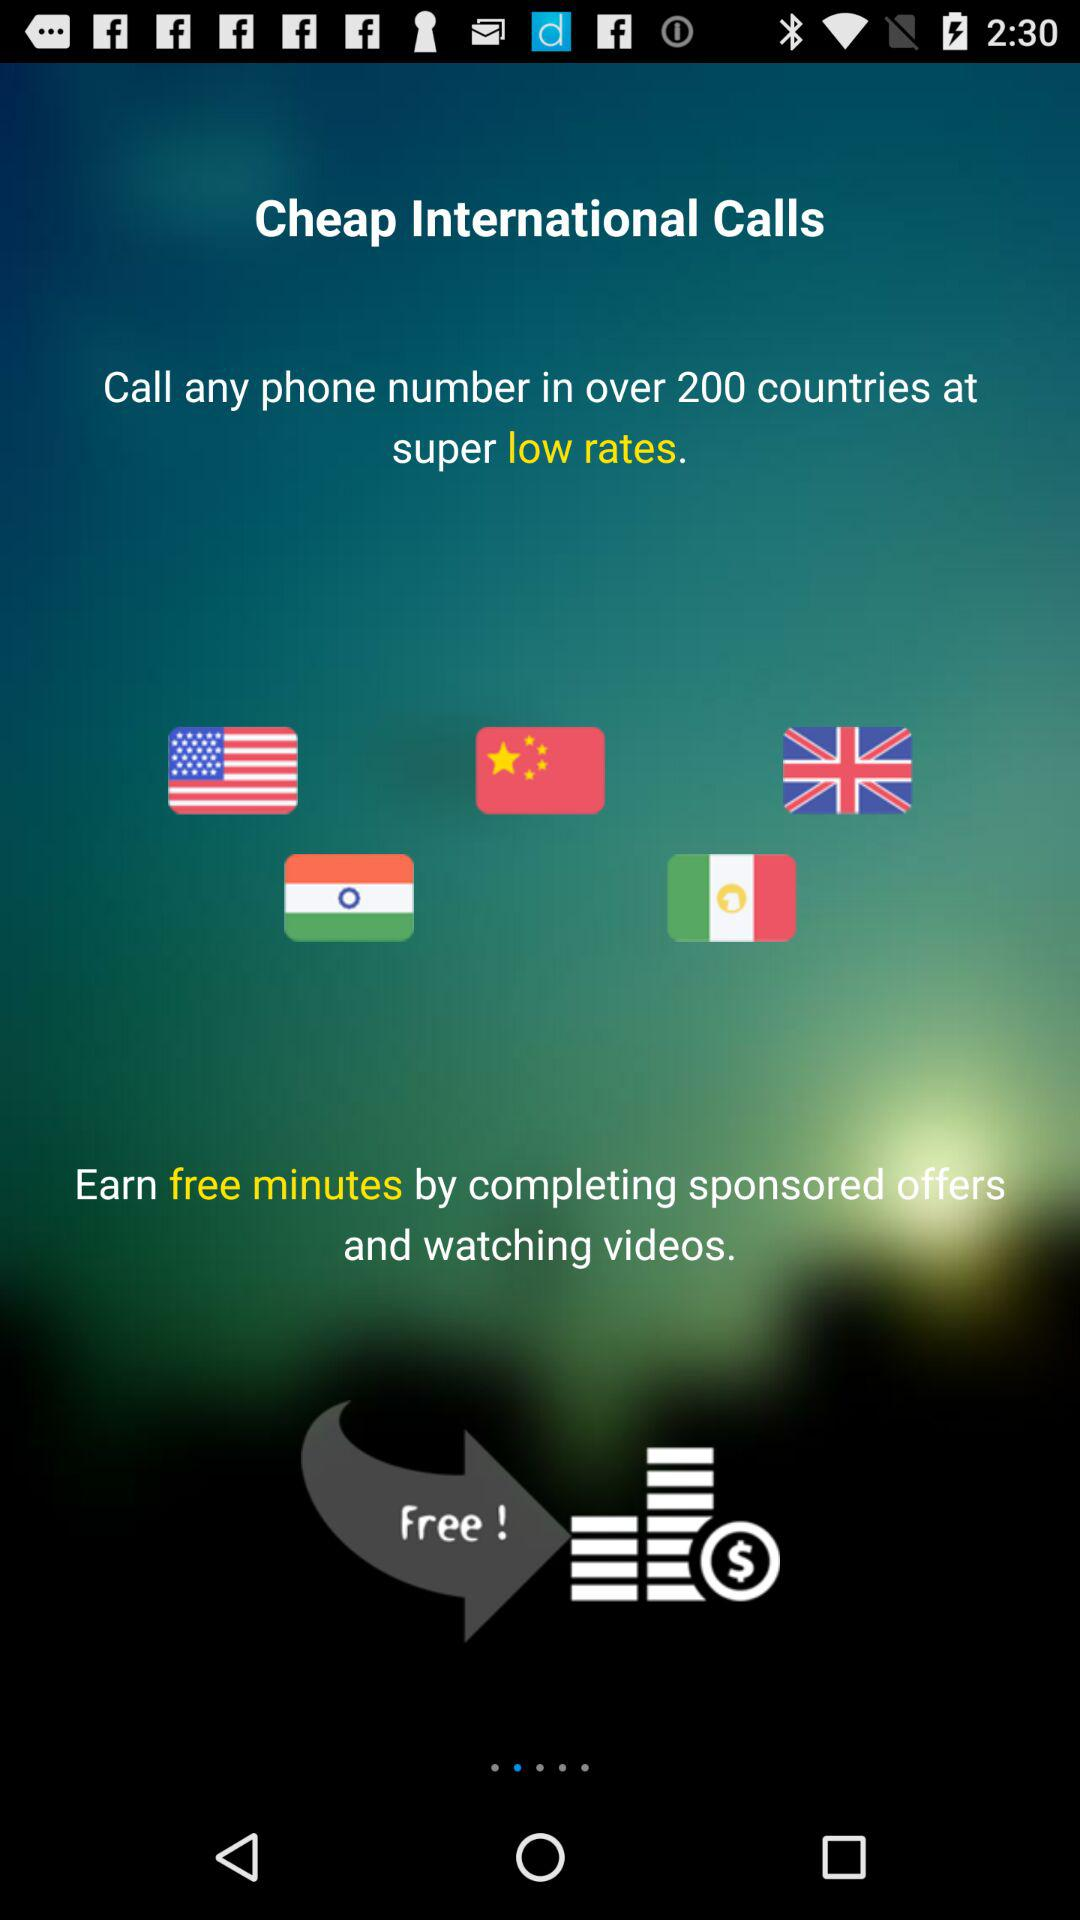What is the version of this application?
When the provided information is insufficient, respond with <no answer>. <no answer> 